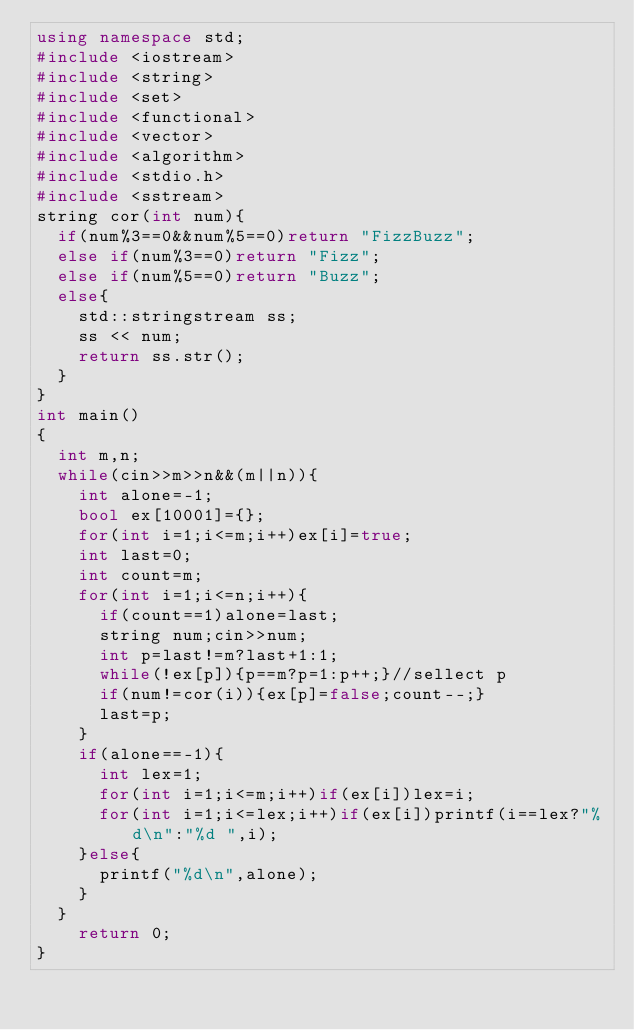<code> <loc_0><loc_0><loc_500><loc_500><_C++_>using namespace std;
#include <iostream>
#include <string>
#include <set>
#include <functional>
#include <vector>
#include <algorithm>
#include <stdio.h>
#include <sstream>
string cor(int num){
	if(num%3==0&&num%5==0)return "FizzBuzz";
	else if(num%3==0)return "Fizz";
	else if(num%5==0)return "Buzz";
	else{
		std::stringstream ss;
		ss << num;
		return ss.str();
	}
}
int main()
{
	int m,n;
	while(cin>>m>>n&&(m||n)){
		int alone=-1;
		bool ex[10001]={};
		for(int i=1;i<=m;i++)ex[i]=true;
		int last=0;
		int count=m;
		for(int i=1;i<=n;i++){
			if(count==1)alone=last;
			string num;cin>>num;
			int p=last!=m?last+1:1;
			while(!ex[p]){p==m?p=1:p++;}//sellect p
			if(num!=cor(i)){ex[p]=false;count--;}
			last=p;
		}
		if(alone==-1){
			int lex=1;
			for(int i=1;i<=m;i++)if(ex[i])lex=i;
			for(int i=1;i<=lex;i++)if(ex[i])printf(i==lex?"%d\n":"%d ",i);
		}else{
			printf("%d\n",alone);
		}
	}
    return 0;
}</code> 